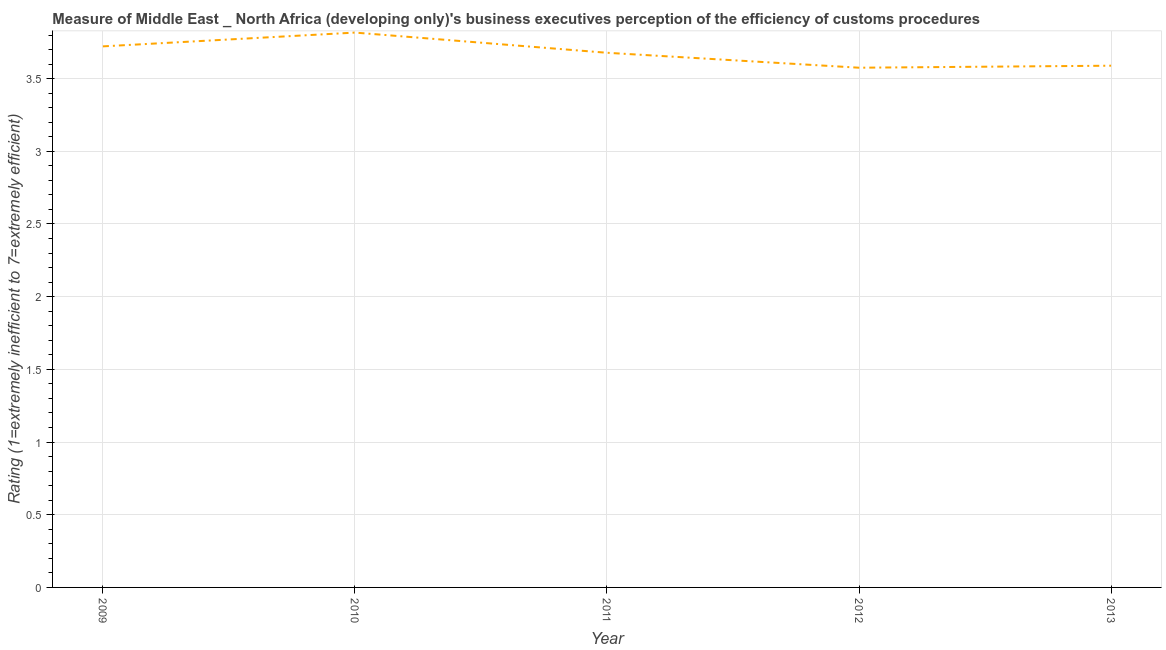What is the rating measuring burden of customs procedure in 2009?
Your answer should be very brief. 3.72. Across all years, what is the maximum rating measuring burden of customs procedure?
Offer a terse response. 3.82. Across all years, what is the minimum rating measuring burden of customs procedure?
Offer a very short reply. 3.58. In which year was the rating measuring burden of customs procedure maximum?
Your response must be concise. 2010. In which year was the rating measuring burden of customs procedure minimum?
Make the answer very short. 2012. What is the sum of the rating measuring burden of customs procedure?
Your answer should be very brief. 18.38. What is the difference between the rating measuring burden of customs procedure in 2009 and 2012?
Your answer should be compact. 0.15. What is the average rating measuring burden of customs procedure per year?
Your response must be concise. 3.68. What is the median rating measuring burden of customs procedure?
Your response must be concise. 3.68. What is the ratio of the rating measuring burden of customs procedure in 2010 to that in 2013?
Offer a very short reply. 1.06. What is the difference between the highest and the second highest rating measuring burden of customs procedure?
Your answer should be compact. 0.09. What is the difference between the highest and the lowest rating measuring burden of customs procedure?
Make the answer very short. 0.24. In how many years, is the rating measuring burden of customs procedure greater than the average rating measuring burden of customs procedure taken over all years?
Provide a short and direct response. 3. Does the rating measuring burden of customs procedure monotonically increase over the years?
Ensure brevity in your answer.  No. How many years are there in the graph?
Offer a terse response. 5. Does the graph contain any zero values?
Provide a short and direct response. No. What is the title of the graph?
Provide a succinct answer. Measure of Middle East _ North Africa (developing only)'s business executives perception of the efficiency of customs procedures. What is the label or title of the X-axis?
Your answer should be compact. Year. What is the label or title of the Y-axis?
Offer a very short reply. Rating (1=extremely inefficient to 7=extremely efficient). What is the Rating (1=extremely inefficient to 7=extremely efficient) in 2009?
Your answer should be very brief. 3.72. What is the Rating (1=extremely inefficient to 7=extremely efficient) of 2010?
Provide a short and direct response. 3.82. What is the Rating (1=extremely inefficient to 7=extremely efficient) of 2011?
Make the answer very short. 3.68. What is the Rating (1=extremely inefficient to 7=extremely efficient) of 2012?
Offer a very short reply. 3.58. What is the Rating (1=extremely inefficient to 7=extremely efficient) in 2013?
Give a very brief answer. 3.59. What is the difference between the Rating (1=extremely inefficient to 7=extremely efficient) in 2009 and 2010?
Your answer should be very brief. -0.09. What is the difference between the Rating (1=extremely inefficient to 7=extremely efficient) in 2009 and 2011?
Your response must be concise. 0.04. What is the difference between the Rating (1=extremely inefficient to 7=extremely efficient) in 2009 and 2012?
Offer a very short reply. 0.15. What is the difference between the Rating (1=extremely inefficient to 7=extremely efficient) in 2009 and 2013?
Ensure brevity in your answer.  0.13. What is the difference between the Rating (1=extremely inefficient to 7=extremely efficient) in 2010 and 2011?
Your response must be concise. 0.14. What is the difference between the Rating (1=extremely inefficient to 7=extremely efficient) in 2010 and 2012?
Offer a terse response. 0.24. What is the difference between the Rating (1=extremely inefficient to 7=extremely efficient) in 2010 and 2013?
Your answer should be compact. 0.23. What is the difference between the Rating (1=extremely inefficient to 7=extremely efficient) in 2011 and 2012?
Keep it short and to the point. 0.1. What is the difference between the Rating (1=extremely inefficient to 7=extremely efficient) in 2011 and 2013?
Your response must be concise. 0.09. What is the difference between the Rating (1=extremely inefficient to 7=extremely efficient) in 2012 and 2013?
Give a very brief answer. -0.01. What is the ratio of the Rating (1=extremely inefficient to 7=extremely efficient) in 2009 to that in 2011?
Your response must be concise. 1.01. What is the ratio of the Rating (1=extremely inefficient to 7=extremely efficient) in 2009 to that in 2012?
Your response must be concise. 1.04. What is the ratio of the Rating (1=extremely inefficient to 7=extremely efficient) in 2010 to that in 2011?
Make the answer very short. 1.04. What is the ratio of the Rating (1=extremely inefficient to 7=extremely efficient) in 2010 to that in 2012?
Give a very brief answer. 1.07. What is the ratio of the Rating (1=extremely inefficient to 7=extremely efficient) in 2010 to that in 2013?
Offer a terse response. 1.06. What is the ratio of the Rating (1=extremely inefficient to 7=extremely efficient) in 2011 to that in 2012?
Make the answer very short. 1.03. What is the ratio of the Rating (1=extremely inefficient to 7=extremely efficient) in 2012 to that in 2013?
Your answer should be compact. 1. 